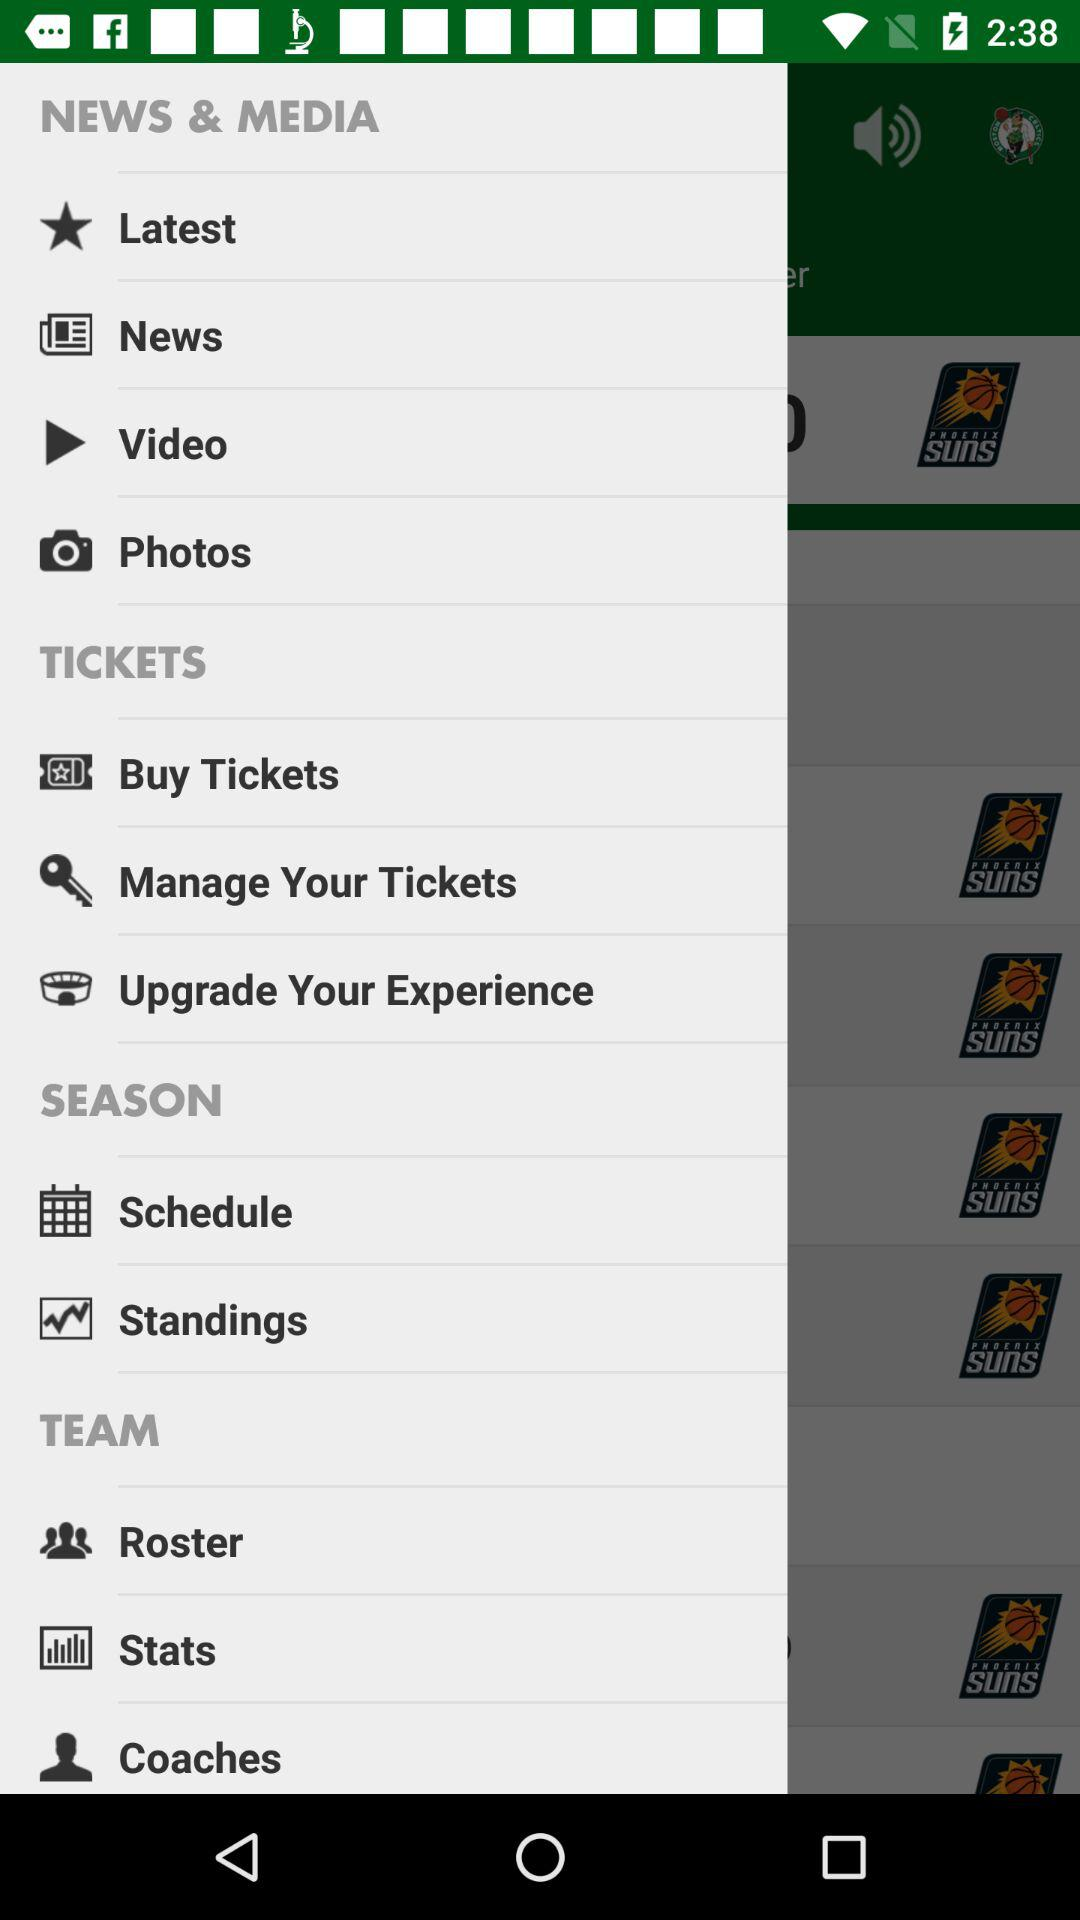How many items are in the news and media section?
Answer the question using a single word or phrase. 4 